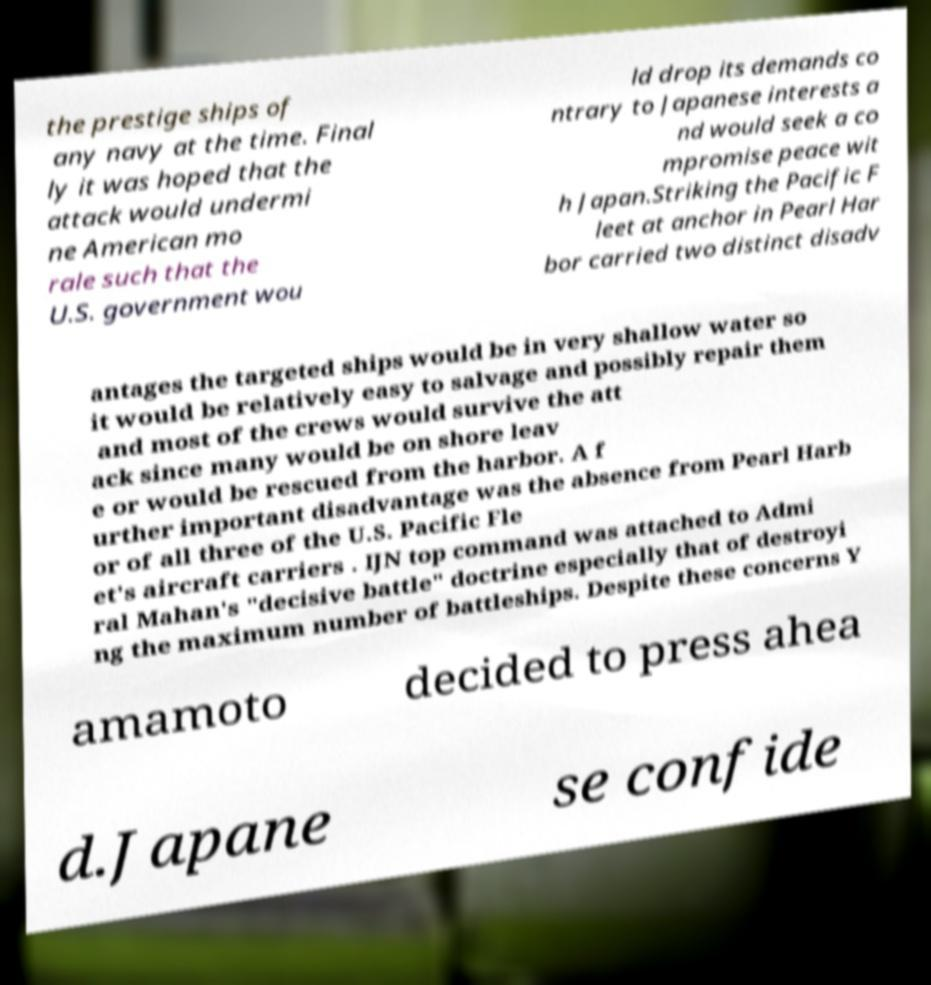Could you extract and type out the text from this image? the prestige ships of any navy at the time. Final ly it was hoped that the attack would undermi ne American mo rale such that the U.S. government wou ld drop its demands co ntrary to Japanese interests a nd would seek a co mpromise peace wit h Japan.Striking the Pacific F leet at anchor in Pearl Har bor carried two distinct disadv antages the targeted ships would be in very shallow water so it would be relatively easy to salvage and possibly repair them and most of the crews would survive the att ack since many would be on shore leav e or would be rescued from the harbor. A f urther important disadvantage was the absence from Pearl Harb or of all three of the U.S. Pacific Fle et's aircraft carriers . IJN top command was attached to Admi ral Mahan's "decisive battle" doctrine especially that of destroyi ng the maximum number of battleships. Despite these concerns Y amamoto decided to press ahea d.Japane se confide 